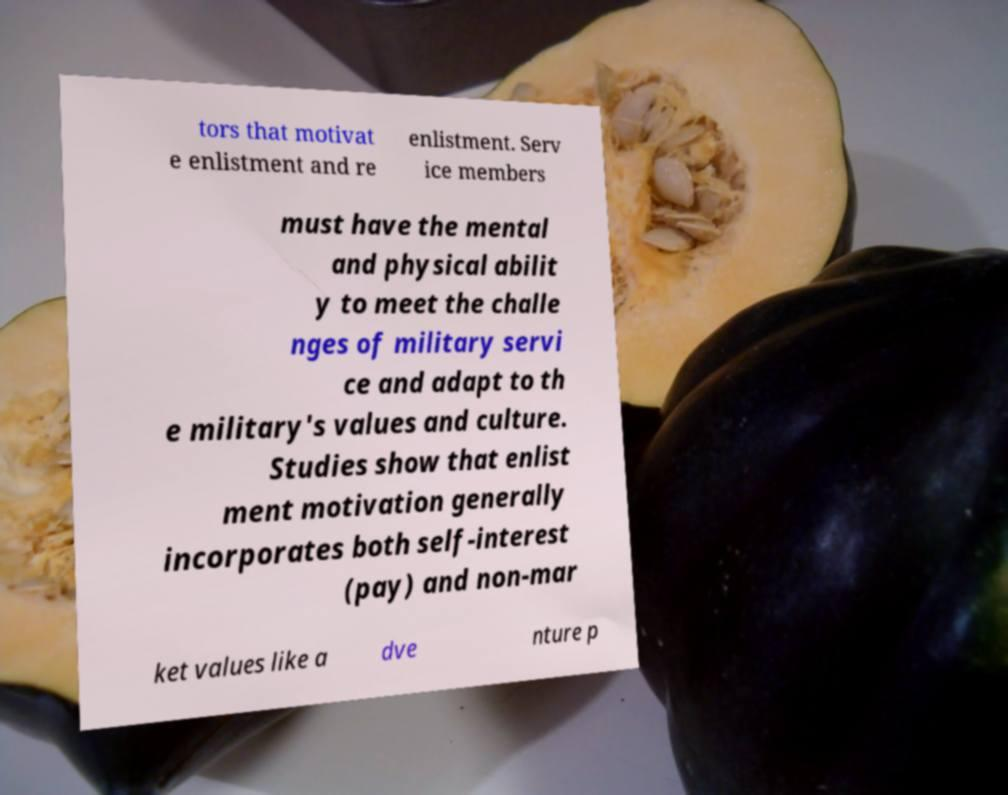Please identify and transcribe the text found in this image. tors that motivat e enlistment and re enlistment. Serv ice members must have the mental and physical abilit y to meet the challe nges of military servi ce and adapt to th e military's values and culture. Studies show that enlist ment motivation generally incorporates both self-interest (pay) and non-mar ket values like a dve nture p 